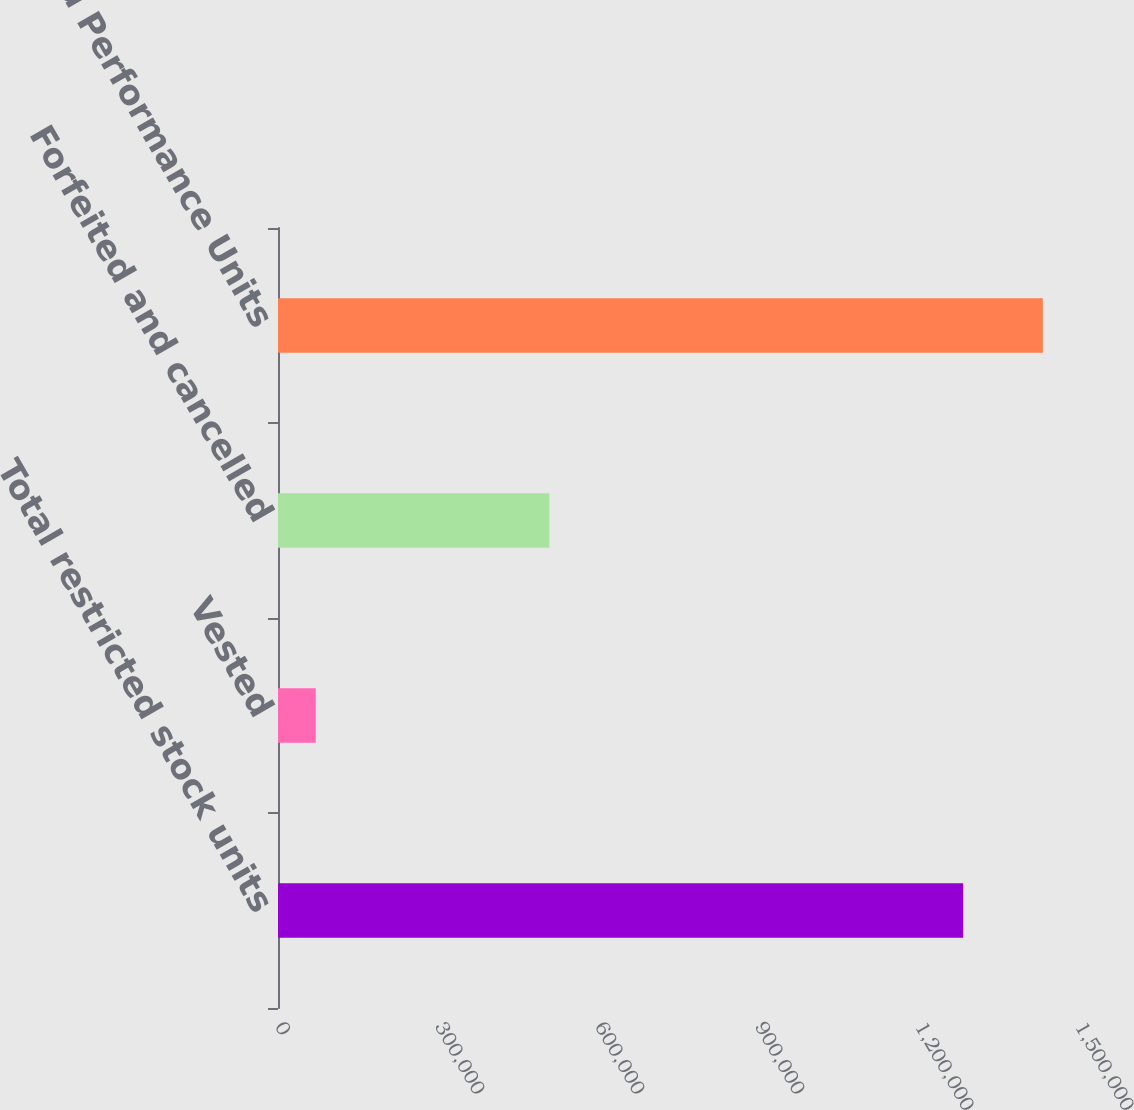<chart> <loc_0><loc_0><loc_500><loc_500><bar_chart><fcel>Total restricted stock units<fcel>Vested<fcel>Forfeited and cancelled<fcel>Restricted Performance Units<nl><fcel>1.28471e+06<fcel>70830<fcel>508794<fcel>1.43406e+06<nl></chart> 